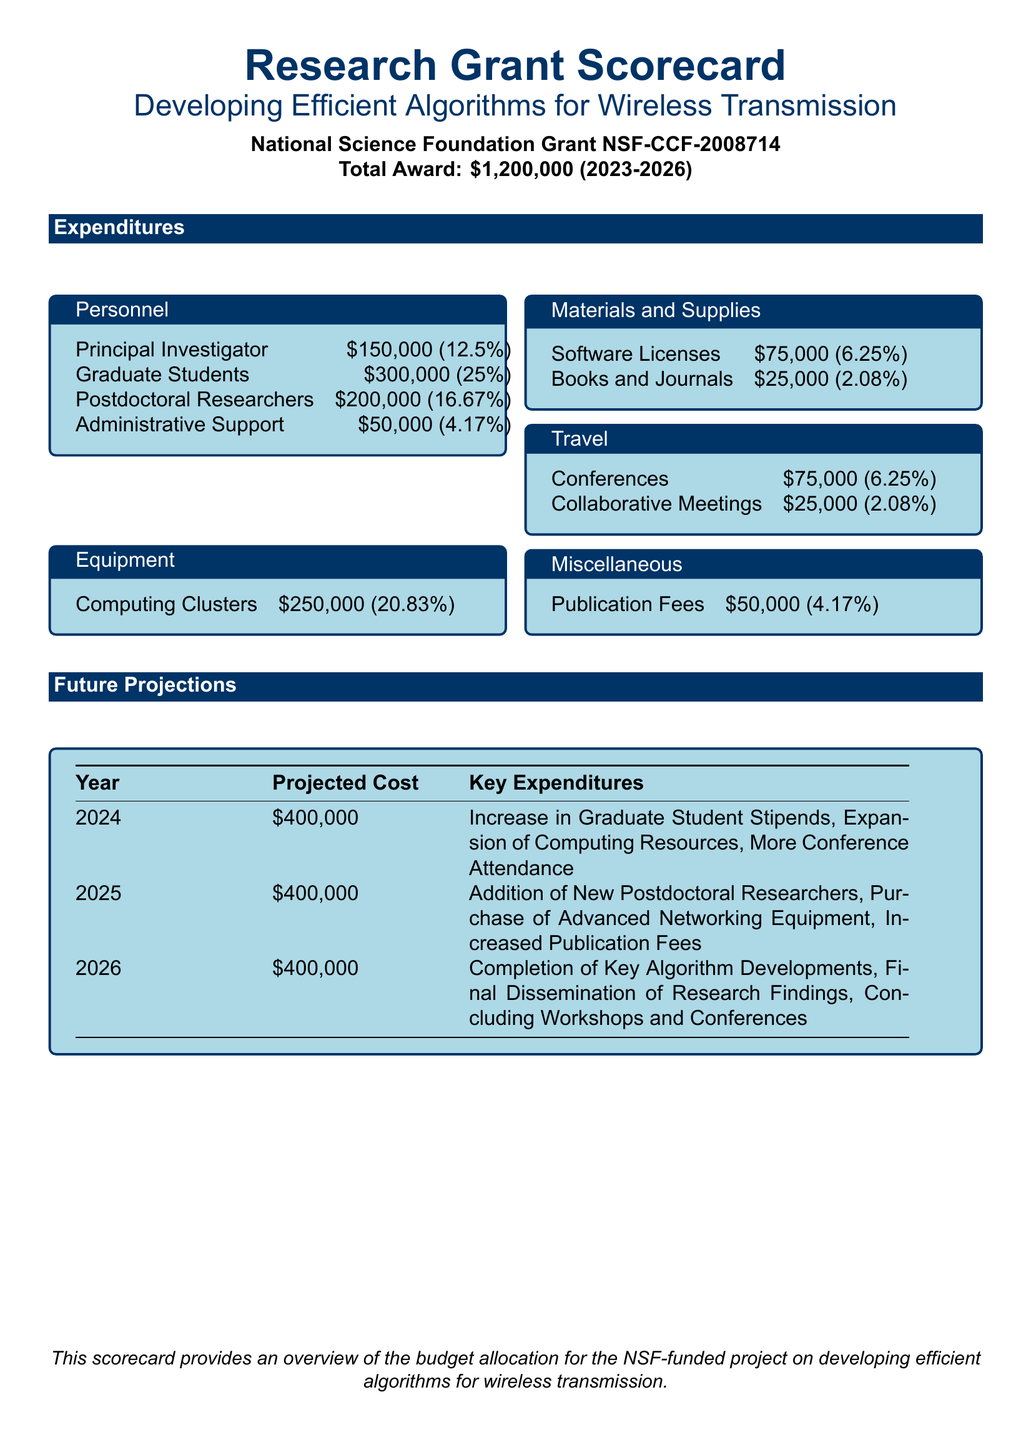What is the total award amount for the grant? The total award amount for the grant is clearly stated in the document as $1,200,000.
Answer: $1,200,000 How much is allocated for Graduate Students? The document specifies that Graduate Students are allocated $300,000, which is 25% of the total budget.
Answer: $300,000 What percentage of the budget is designated for Computing Clusters? According to the expenditures section, Computing Clusters make up 20.83% of the budget.
Answer: 20.83% What is the projected cost for 2024? The future projections table indicates that the projected cost for the year 2024 is $400,000.
Answer: $400,000 Which category has the least expenditure? The Materials and Supplies category has the least expenditure, with a total allocation of $100,000.
Answer: Materials and Supplies What are the key expenditures for the year 2025? The document lists the key expenditures for 2025 as Addition of New Postdoctoral Researchers, Purchase of Advanced Networking Equipment, Increased Publication Fees.
Answer: Addition of New Postdoctoral Researchers, Purchase of Advanced Networking Equipment, Increased Publication Fees Who is the Principal Investigator and how much is allocated for them? The document shows that the Principal Investigator is allocated $150,000, which is 12.5% of the budget.
Answer: $150,000 What is the purpose of this scorecard? The purpose of the scorecard, as stated at the bottom of the document, is to provide an overview of the budget allocation for the NSF-funded project on developing efficient algorithms for wireless transmission.
Answer: Overview of the budget allocation for the NSF-funded project What is the total expenditure on Travel? The total expenditure on Travel, as outlined in the document, is $100,000.
Answer: $100,000 What type of project is this grant funding? The document specifies that the grant is funding a project aimed at developing efficient algorithms for wireless transmission.
Answer: Developing efficient algorithms for wireless transmission 